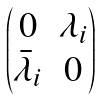<formula> <loc_0><loc_0><loc_500><loc_500>\begin{pmatrix} 0 & \lambda _ { i } \\ \bar { \lambda } _ { i } & 0 \end{pmatrix}</formula> 